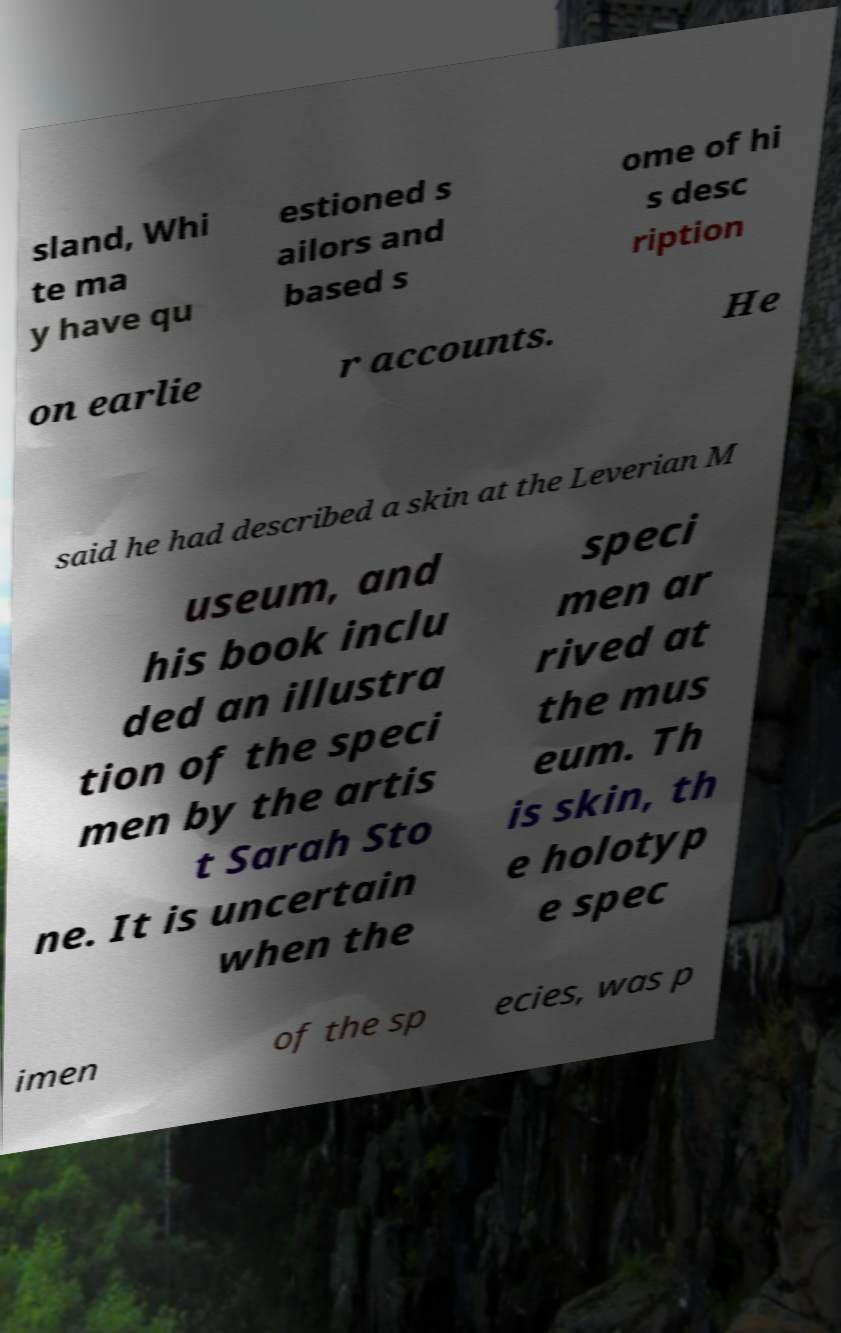Could you assist in decoding the text presented in this image and type it out clearly? sland, Whi te ma y have qu estioned s ailors and based s ome of hi s desc ription on earlie r accounts. He said he had described a skin at the Leverian M useum, and his book inclu ded an illustra tion of the speci men by the artis t Sarah Sto ne. It is uncertain when the speci men ar rived at the mus eum. Th is skin, th e holotyp e spec imen of the sp ecies, was p 